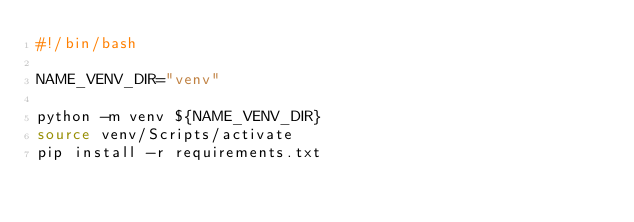Convert code to text. <code><loc_0><loc_0><loc_500><loc_500><_Bash_>#!/bin/bash

NAME_VENV_DIR="venv"

python -m venv ${NAME_VENV_DIR}
source venv/Scripts/activate
pip install -r requirements.txt</code> 